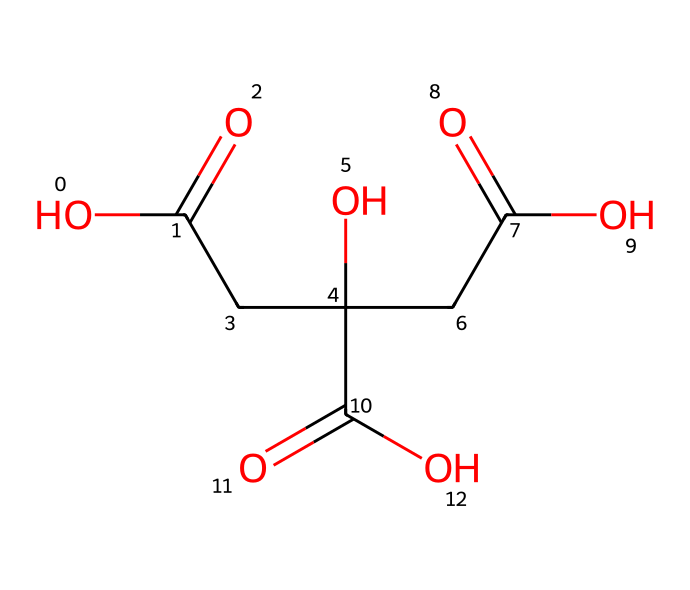how many carbon atoms are present in citric acid? The SMILES representation shows three "C" characters, indicating three carbon atoms in the structure of citric acid.
Answer: three what is the functional group indicated in the structure? The structure contains multiple "C(=O)" which indicates the presence of carboxylic acid functional groups.
Answer: carboxylic acid how many hydroxyl (-OH) groups are present in the citric acid structure? Analyzing the structure, there are two "O" characters that are bonded with "H" indicating two hydroxyl groups (-OH).
Answer: two does citric acid act as an acid or a base? The presence of multiple carboxylic acid groups and their ability to donate protons confirms that citric acid acts as an acid.
Answer: acid how many total oxygen atoms does citric acid contain? Counting the "O" characters in the structure shows there are six oxygen atoms present within the entire structure of citric acid.
Answer: six what type of non-electrolyte is citric acid? Citric acid is a weak organic acid that is a non-electrolyte because it does not completely ionize in water, thus affecting its conductivity.
Answer: weak organic acid what is the pH effect of citric acid in cleaning solutions? Citric acid contributes to an acidic pH when dissolved in cleaning solutions, which can help in breaking down mineral deposits and grease.
Answer: acidic 